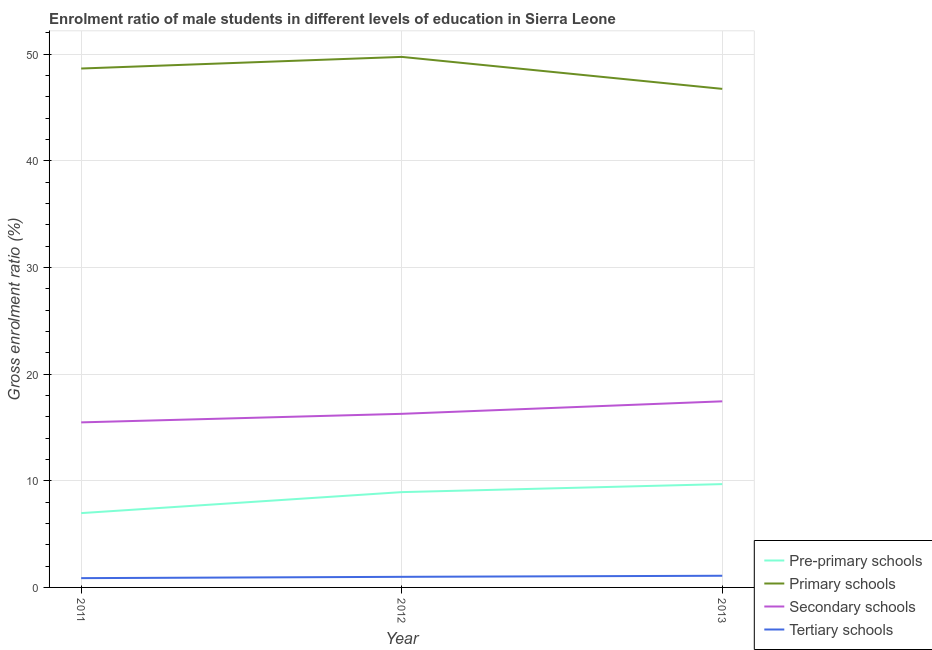How many different coloured lines are there?
Give a very brief answer. 4. Is the number of lines equal to the number of legend labels?
Ensure brevity in your answer.  Yes. What is the gross enrolment ratio(female) in tertiary schools in 2012?
Ensure brevity in your answer.  0.99. Across all years, what is the maximum gross enrolment ratio(female) in pre-primary schools?
Your response must be concise. 9.69. Across all years, what is the minimum gross enrolment ratio(female) in secondary schools?
Provide a succinct answer. 15.48. In which year was the gross enrolment ratio(female) in secondary schools maximum?
Keep it short and to the point. 2013. In which year was the gross enrolment ratio(female) in secondary schools minimum?
Keep it short and to the point. 2011. What is the total gross enrolment ratio(female) in tertiary schools in the graph?
Make the answer very short. 2.96. What is the difference between the gross enrolment ratio(female) in pre-primary schools in 2012 and that in 2013?
Make the answer very short. -0.75. What is the difference between the gross enrolment ratio(female) in primary schools in 2012 and the gross enrolment ratio(female) in pre-primary schools in 2013?
Keep it short and to the point. 40.06. What is the average gross enrolment ratio(female) in pre-primary schools per year?
Provide a short and direct response. 8.53. In the year 2012, what is the difference between the gross enrolment ratio(female) in secondary schools and gross enrolment ratio(female) in primary schools?
Provide a succinct answer. -33.47. What is the ratio of the gross enrolment ratio(female) in tertiary schools in 2011 to that in 2013?
Ensure brevity in your answer.  0.8. Is the gross enrolment ratio(female) in secondary schools in 2011 less than that in 2012?
Ensure brevity in your answer.  Yes. What is the difference between the highest and the second highest gross enrolment ratio(female) in secondary schools?
Offer a very short reply. 1.17. What is the difference between the highest and the lowest gross enrolment ratio(female) in secondary schools?
Keep it short and to the point. 1.97. In how many years, is the gross enrolment ratio(female) in pre-primary schools greater than the average gross enrolment ratio(female) in pre-primary schools taken over all years?
Your answer should be compact. 2. Is it the case that in every year, the sum of the gross enrolment ratio(female) in tertiary schools and gross enrolment ratio(female) in primary schools is greater than the sum of gross enrolment ratio(female) in secondary schools and gross enrolment ratio(female) in pre-primary schools?
Keep it short and to the point. No. Is it the case that in every year, the sum of the gross enrolment ratio(female) in pre-primary schools and gross enrolment ratio(female) in primary schools is greater than the gross enrolment ratio(female) in secondary schools?
Your response must be concise. Yes. Is the gross enrolment ratio(female) in primary schools strictly greater than the gross enrolment ratio(female) in tertiary schools over the years?
Give a very brief answer. Yes. How many lines are there?
Provide a succinct answer. 4. How many years are there in the graph?
Ensure brevity in your answer.  3. What is the difference between two consecutive major ticks on the Y-axis?
Ensure brevity in your answer.  10. Are the values on the major ticks of Y-axis written in scientific E-notation?
Provide a succinct answer. No. What is the title of the graph?
Offer a terse response. Enrolment ratio of male students in different levels of education in Sierra Leone. Does "Financial sector" appear as one of the legend labels in the graph?
Your response must be concise. No. What is the Gross enrolment ratio (%) of Pre-primary schools in 2011?
Provide a short and direct response. 6.97. What is the Gross enrolment ratio (%) of Primary schools in 2011?
Provide a succinct answer. 48.66. What is the Gross enrolment ratio (%) of Secondary schools in 2011?
Provide a short and direct response. 15.48. What is the Gross enrolment ratio (%) of Tertiary schools in 2011?
Make the answer very short. 0.87. What is the Gross enrolment ratio (%) of Pre-primary schools in 2012?
Your response must be concise. 8.94. What is the Gross enrolment ratio (%) of Primary schools in 2012?
Give a very brief answer. 49.75. What is the Gross enrolment ratio (%) of Secondary schools in 2012?
Offer a very short reply. 16.28. What is the Gross enrolment ratio (%) in Tertiary schools in 2012?
Ensure brevity in your answer.  0.99. What is the Gross enrolment ratio (%) of Pre-primary schools in 2013?
Ensure brevity in your answer.  9.69. What is the Gross enrolment ratio (%) of Primary schools in 2013?
Your answer should be very brief. 46.75. What is the Gross enrolment ratio (%) of Secondary schools in 2013?
Provide a succinct answer. 17.45. What is the Gross enrolment ratio (%) in Tertiary schools in 2013?
Give a very brief answer. 1.09. Across all years, what is the maximum Gross enrolment ratio (%) of Pre-primary schools?
Your answer should be very brief. 9.69. Across all years, what is the maximum Gross enrolment ratio (%) in Primary schools?
Your answer should be compact. 49.75. Across all years, what is the maximum Gross enrolment ratio (%) in Secondary schools?
Your answer should be compact. 17.45. Across all years, what is the maximum Gross enrolment ratio (%) in Tertiary schools?
Provide a short and direct response. 1.09. Across all years, what is the minimum Gross enrolment ratio (%) in Pre-primary schools?
Your answer should be very brief. 6.97. Across all years, what is the minimum Gross enrolment ratio (%) in Primary schools?
Your answer should be compact. 46.75. Across all years, what is the minimum Gross enrolment ratio (%) of Secondary schools?
Offer a very short reply. 15.48. Across all years, what is the minimum Gross enrolment ratio (%) of Tertiary schools?
Your response must be concise. 0.87. What is the total Gross enrolment ratio (%) of Pre-primary schools in the graph?
Keep it short and to the point. 25.6. What is the total Gross enrolment ratio (%) in Primary schools in the graph?
Your response must be concise. 145.17. What is the total Gross enrolment ratio (%) in Secondary schools in the graph?
Provide a succinct answer. 49.21. What is the total Gross enrolment ratio (%) of Tertiary schools in the graph?
Ensure brevity in your answer.  2.96. What is the difference between the Gross enrolment ratio (%) of Pre-primary schools in 2011 and that in 2012?
Keep it short and to the point. -1.97. What is the difference between the Gross enrolment ratio (%) in Primary schools in 2011 and that in 2012?
Offer a very short reply. -1.09. What is the difference between the Gross enrolment ratio (%) of Secondary schools in 2011 and that in 2012?
Your response must be concise. -0.8. What is the difference between the Gross enrolment ratio (%) in Tertiary schools in 2011 and that in 2012?
Give a very brief answer. -0.12. What is the difference between the Gross enrolment ratio (%) in Pre-primary schools in 2011 and that in 2013?
Your response must be concise. -2.72. What is the difference between the Gross enrolment ratio (%) of Primary schools in 2011 and that in 2013?
Your answer should be compact. 1.91. What is the difference between the Gross enrolment ratio (%) of Secondary schools in 2011 and that in 2013?
Ensure brevity in your answer.  -1.97. What is the difference between the Gross enrolment ratio (%) in Tertiary schools in 2011 and that in 2013?
Provide a succinct answer. -0.22. What is the difference between the Gross enrolment ratio (%) in Pre-primary schools in 2012 and that in 2013?
Offer a very short reply. -0.75. What is the difference between the Gross enrolment ratio (%) of Primary schools in 2012 and that in 2013?
Keep it short and to the point. 3. What is the difference between the Gross enrolment ratio (%) of Secondary schools in 2012 and that in 2013?
Ensure brevity in your answer.  -1.17. What is the difference between the Gross enrolment ratio (%) of Tertiary schools in 2012 and that in 2013?
Give a very brief answer. -0.1. What is the difference between the Gross enrolment ratio (%) in Pre-primary schools in 2011 and the Gross enrolment ratio (%) in Primary schools in 2012?
Make the answer very short. -42.78. What is the difference between the Gross enrolment ratio (%) of Pre-primary schools in 2011 and the Gross enrolment ratio (%) of Secondary schools in 2012?
Give a very brief answer. -9.31. What is the difference between the Gross enrolment ratio (%) of Pre-primary schools in 2011 and the Gross enrolment ratio (%) of Tertiary schools in 2012?
Ensure brevity in your answer.  5.98. What is the difference between the Gross enrolment ratio (%) in Primary schools in 2011 and the Gross enrolment ratio (%) in Secondary schools in 2012?
Your answer should be compact. 32.38. What is the difference between the Gross enrolment ratio (%) of Primary schools in 2011 and the Gross enrolment ratio (%) of Tertiary schools in 2012?
Provide a succinct answer. 47.67. What is the difference between the Gross enrolment ratio (%) of Secondary schools in 2011 and the Gross enrolment ratio (%) of Tertiary schools in 2012?
Your answer should be compact. 14.48. What is the difference between the Gross enrolment ratio (%) in Pre-primary schools in 2011 and the Gross enrolment ratio (%) in Primary schools in 2013?
Provide a short and direct response. -39.79. What is the difference between the Gross enrolment ratio (%) in Pre-primary schools in 2011 and the Gross enrolment ratio (%) in Secondary schools in 2013?
Your response must be concise. -10.48. What is the difference between the Gross enrolment ratio (%) in Pre-primary schools in 2011 and the Gross enrolment ratio (%) in Tertiary schools in 2013?
Your response must be concise. 5.87. What is the difference between the Gross enrolment ratio (%) of Primary schools in 2011 and the Gross enrolment ratio (%) of Secondary schools in 2013?
Your answer should be compact. 31.21. What is the difference between the Gross enrolment ratio (%) of Primary schools in 2011 and the Gross enrolment ratio (%) of Tertiary schools in 2013?
Your answer should be very brief. 47.57. What is the difference between the Gross enrolment ratio (%) in Secondary schools in 2011 and the Gross enrolment ratio (%) in Tertiary schools in 2013?
Make the answer very short. 14.38. What is the difference between the Gross enrolment ratio (%) in Pre-primary schools in 2012 and the Gross enrolment ratio (%) in Primary schools in 2013?
Provide a succinct answer. -37.82. What is the difference between the Gross enrolment ratio (%) of Pre-primary schools in 2012 and the Gross enrolment ratio (%) of Secondary schools in 2013?
Offer a very short reply. -8.52. What is the difference between the Gross enrolment ratio (%) in Pre-primary schools in 2012 and the Gross enrolment ratio (%) in Tertiary schools in 2013?
Ensure brevity in your answer.  7.84. What is the difference between the Gross enrolment ratio (%) in Primary schools in 2012 and the Gross enrolment ratio (%) in Secondary schools in 2013?
Offer a terse response. 32.3. What is the difference between the Gross enrolment ratio (%) in Primary schools in 2012 and the Gross enrolment ratio (%) in Tertiary schools in 2013?
Your answer should be compact. 48.66. What is the difference between the Gross enrolment ratio (%) of Secondary schools in 2012 and the Gross enrolment ratio (%) of Tertiary schools in 2013?
Your response must be concise. 15.19. What is the average Gross enrolment ratio (%) of Pre-primary schools per year?
Provide a succinct answer. 8.53. What is the average Gross enrolment ratio (%) in Primary schools per year?
Ensure brevity in your answer.  48.39. What is the average Gross enrolment ratio (%) of Secondary schools per year?
Your answer should be compact. 16.4. What is the average Gross enrolment ratio (%) of Tertiary schools per year?
Your response must be concise. 0.99. In the year 2011, what is the difference between the Gross enrolment ratio (%) in Pre-primary schools and Gross enrolment ratio (%) in Primary schools?
Your response must be concise. -41.69. In the year 2011, what is the difference between the Gross enrolment ratio (%) of Pre-primary schools and Gross enrolment ratio (%) of Secondary schools?
Your answer should be compact. -8.51. In the year 2011, what is the difference between the Gross enrolment ratio (%) of Pre-primary schools and Gross enrolment ratio (%) of Tertiary schools?
Provide a succinct answer. 6.1. In the year 2011, what is the difference between the Gross enrolment ratio (%) in Primary schools and Gross enrolment ratio (%) in Secondary schools?
Your response must be concise. 33.19. In the year 2011, what is the difference between the Gross enrolment ratio (%) of Primary schools and Gross enrolment ratio (%) of Tertiary schools?
Your response must be concise. 47.79. In the year 2011, what is the difference between the Gross enrolment ratio (%) of Secondary schools and Gross enrolment ratio (%) of Tertiary schools?
Provide a succinct answer. 14.61. In the year 2012, what is the difference between the Gross enrolment ratio (%) in Pre-primary schools and Gross enrolment ratio (%) in Primary schools?
Keep it short and to the point. -40.82. In the year 2012, what is the difference between the Gross enrolment ratio (%) of Pre-primary schools and Gross enrolment ratio (%) of Secondary schools?
Your answer should be compact. -7.34. In the year 2012, what is the difference between the Gross enrolment ratio (%) of Pre-primary schools and Gross enrolment ratio (%) of Tertiary schools?
Give a very brief answer. 7.94. In the year 2012, what is the difference between the Gross enrolment ratio (%) in Primary schools and Gross enrolment ratio (%) in Secondary schools?
Your answer should be compact. 33.47. In the year 2012, what is the difference between the Gross enrolment ratio (%) in Primary schools and Gross enrolment ratio (%) in Tertiary schools?
Keep it short and to the point. 48.76. In the year 2012, what is the difference between the Gross enrolment ratio (%) of Secondary schools and Gross enrolment ratio (%) of Tertiary schools?
Offer a terse response. 15.29. In the year 2013, what is the difference between the Gross enrolment ratio (%) of Pre-primary schools and Gross enrolment ratio (%) of Primary schools?
Offer a terse response. -37.07. In the year 2013, what is the difference between the Gross enrolment ratio (%) of Pre-primary schools and Gross enrolment ratio (%) of Secondary schools?
Provide a succinct answer. -7.76. In the year 2013, what is the difference between the Gross enrolment ratio (%) of Pre-primary schools and Gross enrolment ratio (%) of Tertiary schools?
Offer a terse response. 8.59. In the year 2013, what is the difference between the Gross enrolment ratio (%) of Primary schools and Gross enrolment ratio (%) of Secondary schools?
Your response must be concise. 29.3. In the year 2013, what is the difference between the Gross enrolment ratio (%) in Primary schools and Gross enrolment ratio (%) in Tertiary schools?
Your answer should be compact. 45.66. In the year 2013, what is the difference between the Gross enrolment ratio (%) of Secondary schools and Gross enrolment ratio (%) of Tertiary schools?
Your answer should be very brief. 16.36. What is the ratio of the Gross enrolment ratio (%) of Pre-primary schools in 2011 to that in 2012?
Provide a succinct answer. 0.78. What is the ratio of the Gross enrolment ratio (%) of Primary schools in 2011 to that in 2012?
Keep it short and to the point. 0.98. What is the ratio of the Gross enrolment ratio (%) in Secondary schools in 2011 to that in 2012?
Give a very brief answer. 0.95. What is the ratio of the Gross enrolment ratio (%) of Tertiary schools in 2011 to that in 2012?
Your answer should be very brief. 0.88. What is the ratio of the Gross enrolment ratio (%) in Pre-primary schools in 2011 to that in 2013?
Offer a terse response. 0.72. What is the ratio of the Gross enrolment ratio (%) in Primary schools in 2011 to that in 2013?
Offer a terse response. 1.04. What is the ratio of the Gross enrolment ratio (%) in Secondary schools in 2011 to that in 2013?
Make the answer very short. 0.89. What is the ratio of the Gross enrolment ratio (%) of Tertiary schools in 2011 to that in 2013?
Provide a succinct answer. 0.8. What is the ratio of the Gross enrolment ratio (%) in Pre-primary schools in 2012 to that in 2013?
Your response must be concise. 0.92. What is the ratio of the Gross enrolment ratio (%) in Primary schools in 2012 to that in 2013?
Your answer should be very brief. 1.06. What is the ratio of the Gross enrolment ratio (%) in Secondary schools in 2012 to that in 2013?
Your response must be concise. 0.93. What is the ratio of the Gross enrolment ratio (%) in Tertiary schools in 2012 to that in 2013?
Provide a succinct answer. 0.91. What is the difference between the highest and the second highest Gross enrolment ratio (%) of Pre-primary schools?
Your answer should be compact. 0.75. What is the difference between the highest and the second highest Gross enrolment ratio (%) in Primary schools?
Keep it short and to the point. 1.09. What is the difference between the highest and the second highest Gross enrolment ratio (%) of Secondary schools?
Give a very brief answer. 1.17. What is the difference between the highest and the second highest Gross enrolment ratio (%) of Tertiary schools?
Your response must be concise. 0.1. What is the difference between the highest and the lowest Gross enrolment ratio (%) of Pre-primary schools?
Offer a very short reply. 2.72. What is the difference between the highest and the lowest Gross enrolment ratio (%) of Primary schools?
Provide a short and direct response. 3. What is the difference between the highest and the lowest Gross enrolment ratio (%) of Secondary schools?
Provide a short and direct response. 1.97. What is the difference between the highest and the lowest Gross enrolment ratio (%) of Tertiary schools?
Offer a terse response. 0.22. 